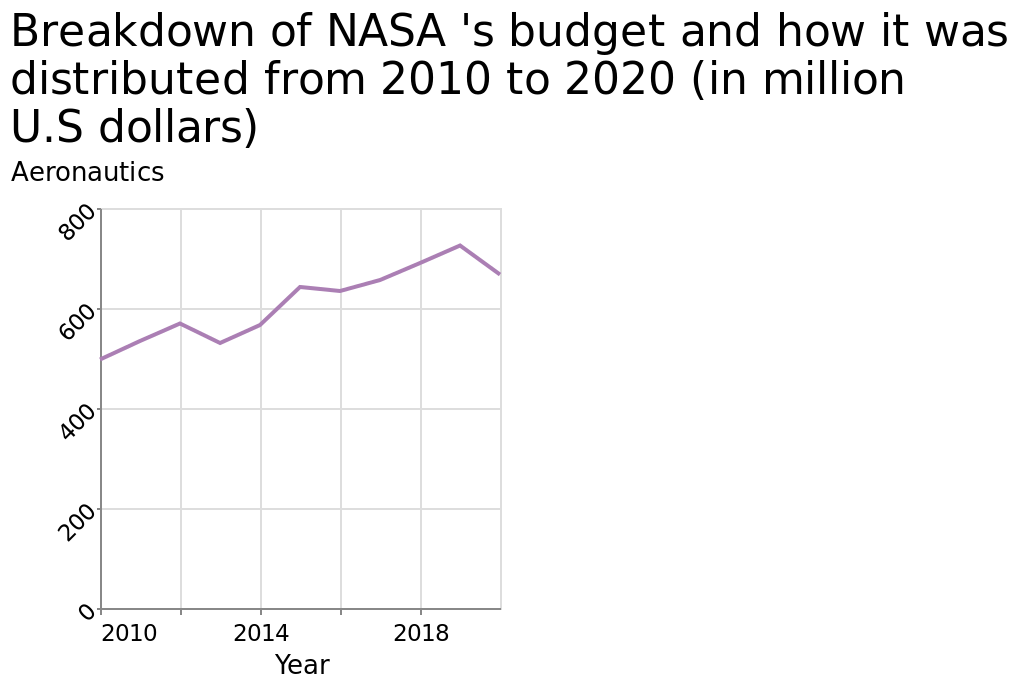<image>
please summary the statistics and relations of the chart The budget increased between 2010 and 2020, from 500 million, to 700 million. 2013, the amount decrease from the previous year. 2015, the amount decreased from the previous year. What is the time range covered by the line diagram?  The line diagram covers the years from 2010 to 2020. please enumerates aspects of the construction of the chart Breakdown of NASA 's budget and how it was distributed from 2010 to 2020 (in million U.S dollars) is a line diagram. The x-axis plots Year while the y-axis plots Aeronautics. What was the budget in 2020? The budget in 2020 was 700 million. 